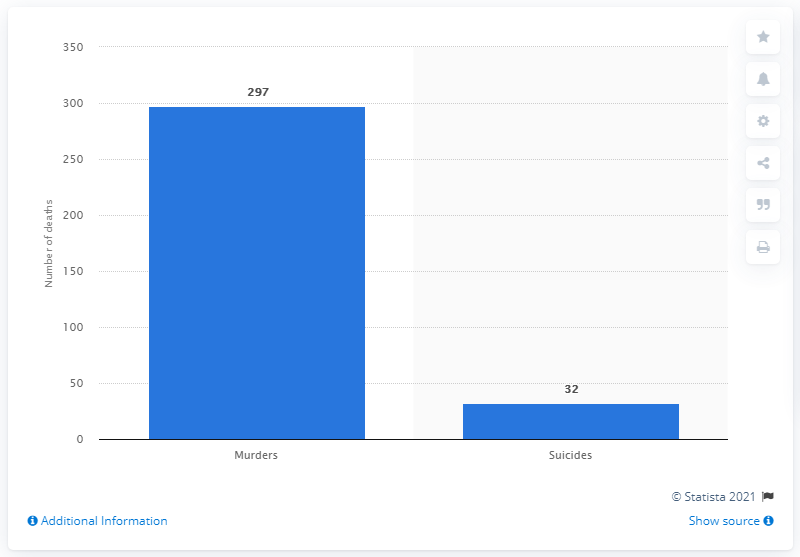Draw attention to some important aspects in this diagram. In 2019, there were 32 reported suicides in Brazil. 